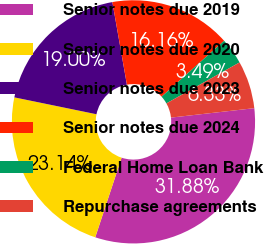<chart> <loc_0><loc_0><loc_500><loc_500><pie_chart><fcel>Senior notes due 2019<fcel>Senior notes due 2020<fcel>Senior notes due 2023<fcel>Senior notes due 2024<fcel>Federal Home Loan Bank<fcel>Repurchase agreements<nl><fcel>31.88%<fcel>23.14%<fcel>19.0%<fcel>16.16%<fcel>3.49%<fcel>6.33%<nl></chart> 